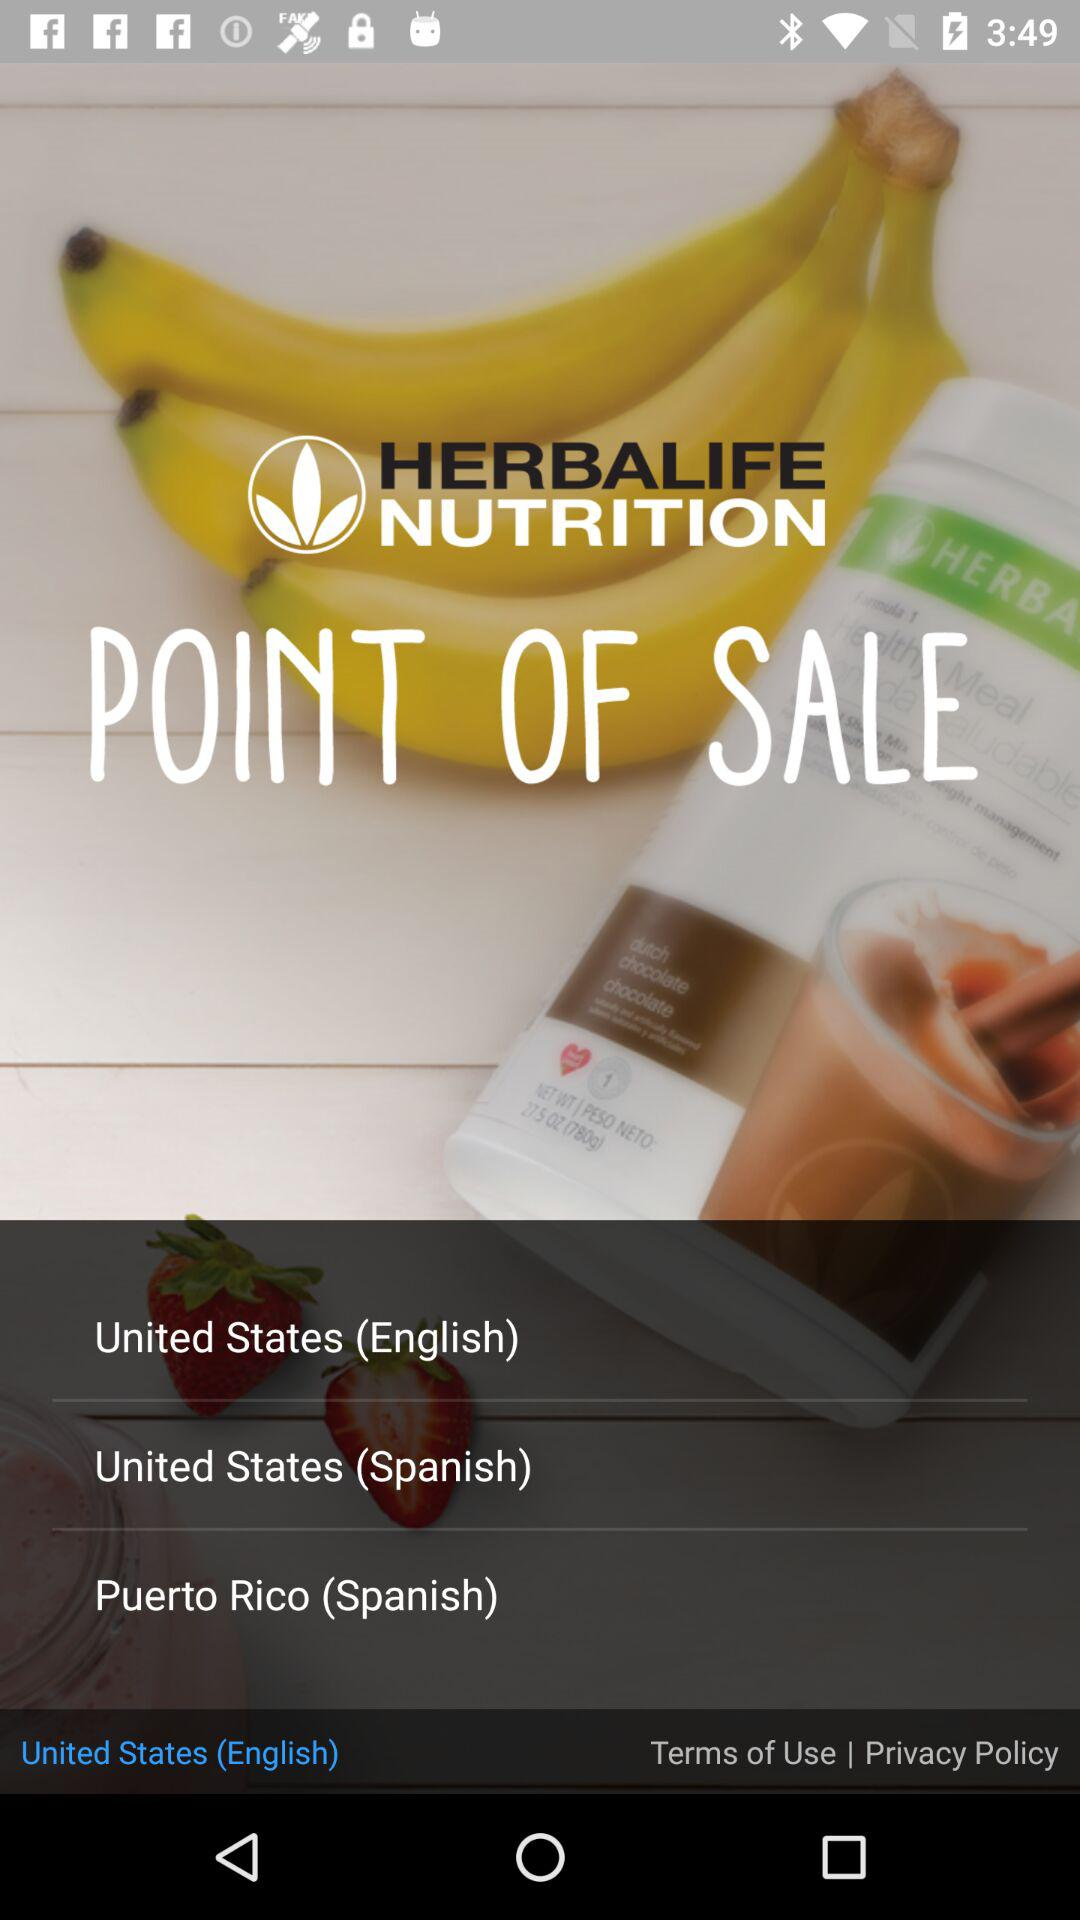What is the application name? The application name is "HERBALIFE NUTRITION". 